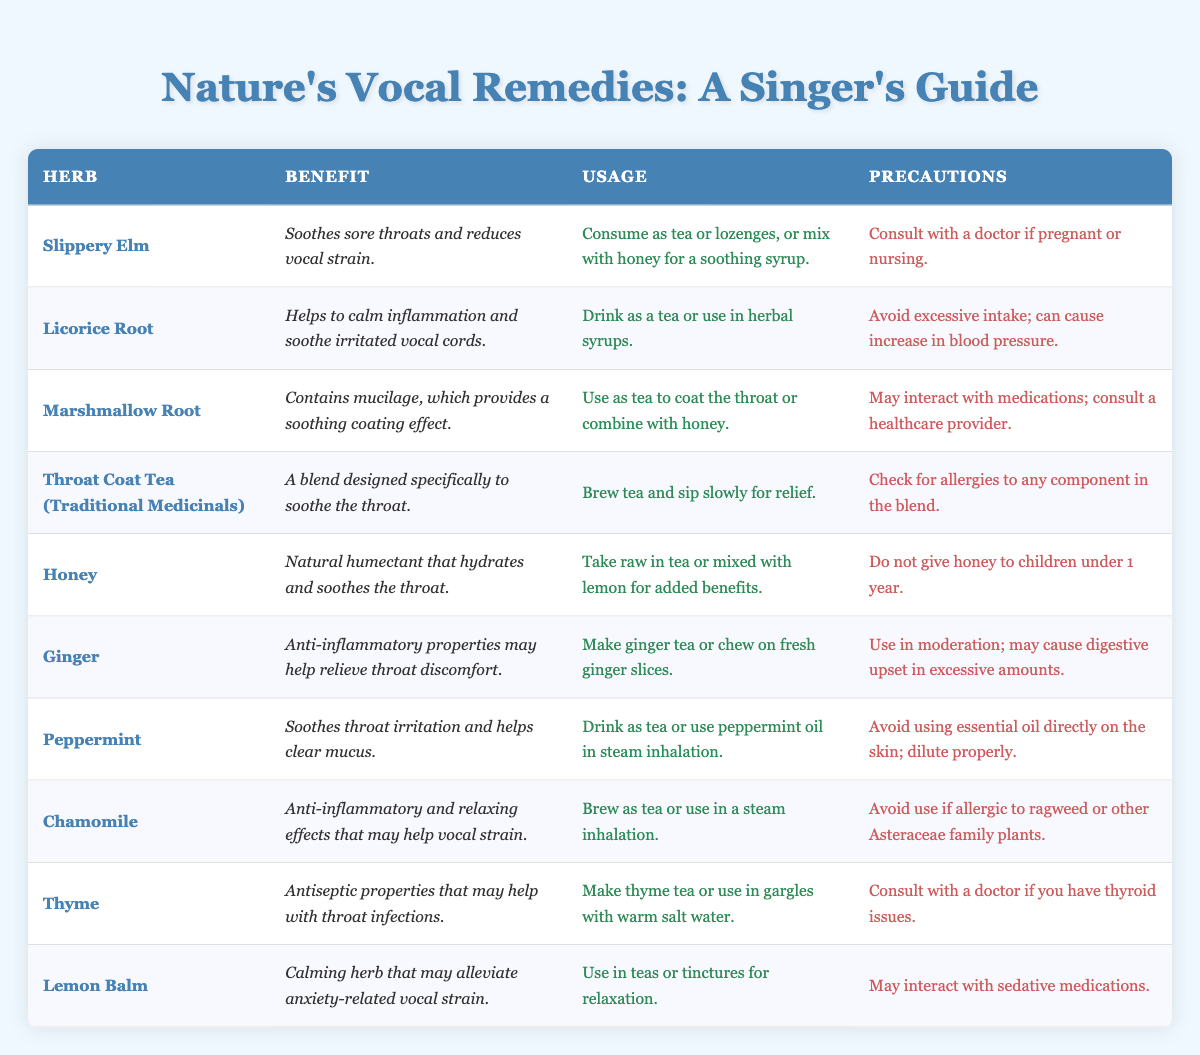What is the benefit of Slippery Elm? According to the table, Slippery Elm is noted for soothing sore throats and reducing vocal strain.
Answer: Soothes sore throats and reduces vocal strain How can you use Licorice Root? The table specifies that Licorice Root can be consumed as a tea or used in herbal syrups.
Answer: Drink as a tea or use in herbal syrups Which herb is effective for throat irritation and also helps clear mucus? By reviewing the benefits column, it can be observed that Peppermint soothes throat irritation and helps clear mucus.
Answer: Peppermint Are there any herbs in the table that can interact with medications? Marshmallow Root and Lemon Balm are both indicated to potentially interact with medications according to the precautions provided.
Answer: Yes What precautions should you take when using Ginger? The table lists that Ginger should be used in moderation as excessive amounts may cause digestive upset.
Answer: Use in moderation How many herbs listed have soothing benefits for the throat? By examining the benefits column, I see that Slippery Elm, Licorice Root, Marshmallow Root, Honey, Ginger, Peppermint, Chamomile, and Throat Coat Tea provide soothing benefits. That's a total of 8 herbs.
Answer: 8 herbs Is Honey safe for children under 1 year? The precautions for Honey state that it should not be given to children under 1 year, indicating it is not safe for them.
Answer: No Which herb should be avoided by individuals allergic to ragweed? The table indicates that Chamomile should be avoided if allergic to ragweed or other Asteraceae family plants.
Answer: Chamomile What is the average number of herbs you can consume in tea form based on the table? The herbs that can be consumed in tea form include Slippery Elm, Licorice Root, Marshmallow Root, Throat Coat Tea, Ginger, Peppermint, Chamomile, and Thyme; this adds up to 8 herbs, indicating it is common to find options for tea consumption. The average is simply the number itself since there are no additional calculations required.
Answer: 8 